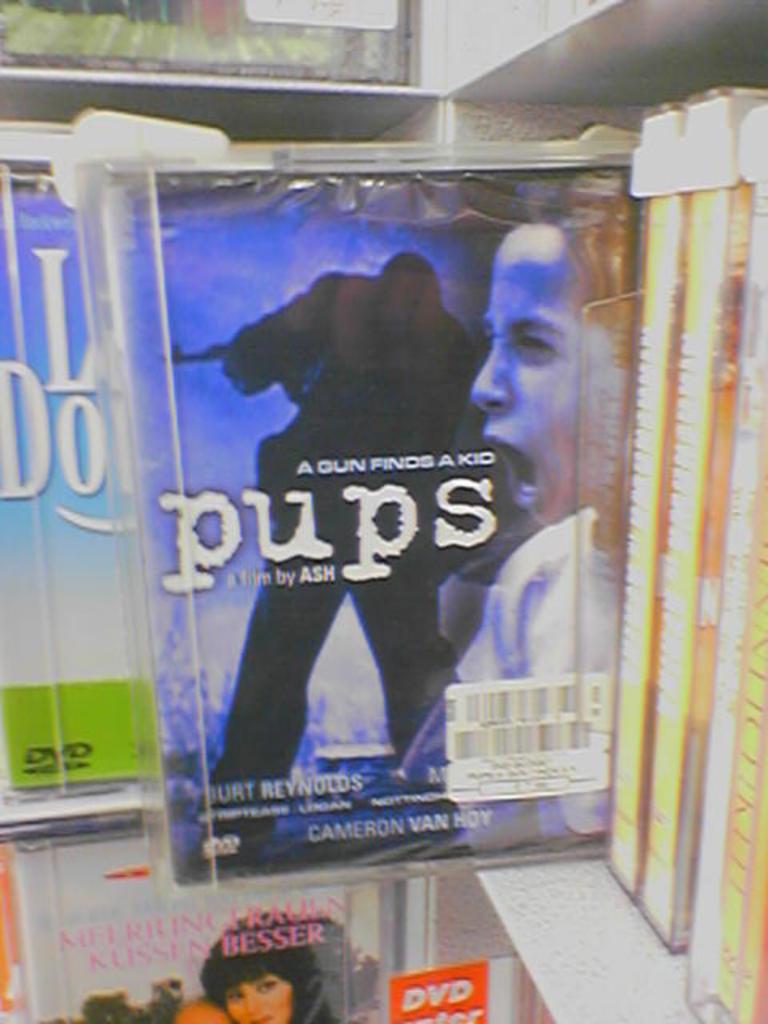What movie is this?
Your response must be concise. Pups. What does the sign at the bottom of the picture say?
Provide a succinct answer. Dvd. 